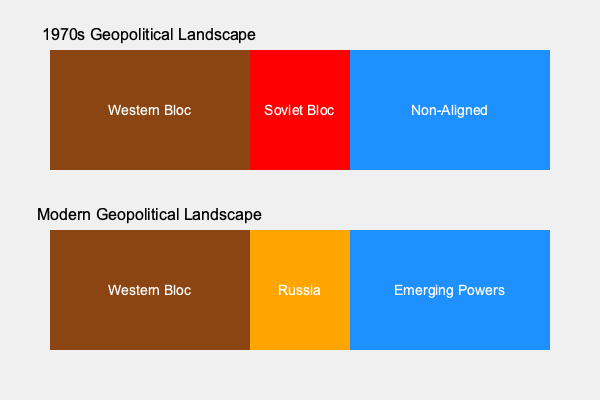Based on the geopolitical maps shown above, what is the most significant change in global power dynamics between the 1970s and today, and how does this reflect the shift from a bipolar to a multipolar world order? To answer this question, we need to analyze the changes depicted in the two maps:

1. 1970s Geopolitical Landscape:
   - The world was divided into three main blocs: Western Bloc, Soviet Bloc, and Non-Aligned countries.
   - This represents a bipolar world order, dominated by two superpowers: the United States (leading the Western Bloc) and the Soviet Union.

2. Modern Geopolitical Landscape:
   - The Western Bloc remains largely unchanged.
   - The Soviet Bloc has been replaced by Russia, which occupies a smaller area, indicating reduced influence.
   - The Non-Aligned countries have been replaced by "Emerging Powers," suggesting a rise in influence of developing nations.

3. Key changes:
   - The collapse of the Soviet Union and the end of the Cold War.
   - The rise of emerging powers, particularly in the former Non-Aligned region.

4. Shift to a multipolar world order:
   - The bipolar system (US vs. USSR) has given way to a more complex, multipolar system.
   - Emerging powers (e.g., China, India, Brazil) have gained significant economic and political influence.
   - Russia's influence has diminished compared to the Soviet era but remains a major player.

5. Implications:
   - More diverse centers of power and influence in global affairs.
   - Increased complexity in international relations and decision-making.
   - Greater potential for both cooperation and conflict among multiple power centers.

The most significant change is the transition from a bipolar world dominated by two superpowers to a multipolar world with multiple centers of influence, as evidenced by the emergence of new power blocs in formerly Non-Aligned regions.
Answer: Transition from bipolar to multipolar world order 